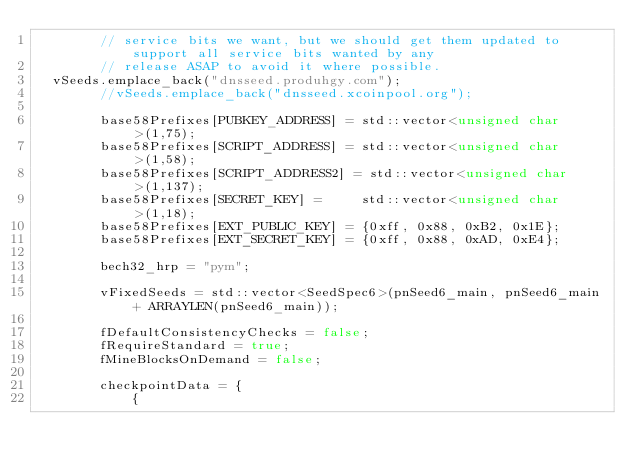Convert code to text. <code><loc_0><loc_0><loc_500><loc_500><_C++_>        // service bits we want, but we should get them updated to support all service bits wanted by any
        // release ASAP to avoid it where possible.
	vSeeds.emplace_back("dnsseed.produhgy.com");
        //vSeeds.emplace_back("dnsseed.xcoinpool.org");

        base58Prefixes[PUBKEY_ADDRESS] = std::vector<unsigned char>(1,75);
        base58Prefixes[SCRIPT_ADDRESS] = std::vector<unsigned char>(1,58);
        base58Prefixes[SCRIPT_ADDRESS2] = std::vector<unsigned char>(1,137);
        base58Prefixes[SECRET_KEY] =     std::vector<unsigned char>(1,18);
        base58Prefixes[EXT_PUBLIC_KEY] = {0xff, 0x88, 0xB2, 0x1E};
        base58Prefixes[EXT_SECRET_KEY] = {0xff, 0x88, 0xAD, 0xE4};

        bech32_hrp = "pym";

        vFixedSeeds = std::vector<SeedSpec6>(pnSeed6_main, pnSeed6_main + ARRAYLEN(pnSeed6_main));

        fDefaultConsistencyChecks = false;
        fRequireStandard = true;
        fMineBlocksOnDemand = false;

        checkpointData = {
            {</code> 